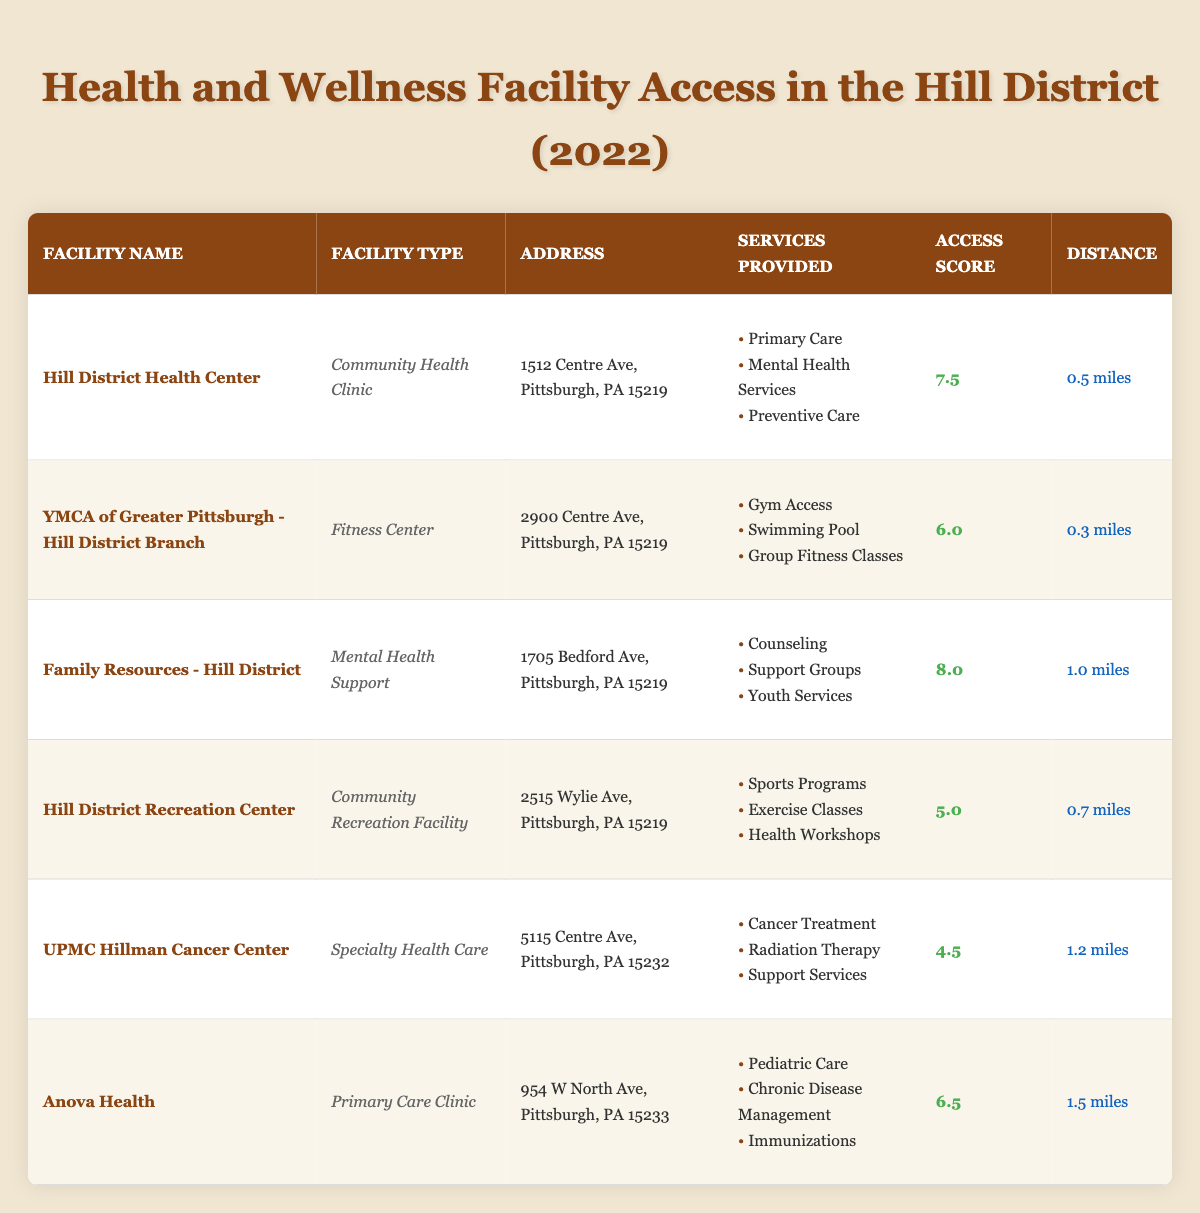What is the access score of the Hill District Health Center? The table lists the access score for the Hill District Health Center as 7.5 under the "Access Score" column.
Answer: 7.5 Which facility is closest to the center? The YMCA of Greater Pittsburgh - Hill District Branch is listed as being 0.3 miles away, which is the shortest distance among all facilities.
Answer: YMCA of Greater Pittsburgh - Hill District Branch What type of services does the Family Resources - Hill District provide? The table shows that Family Resources - Hill District provides counseling, support groups, and youth services, listed under the "Services Provided" column.
Answer: Counseling, Support Groups, Youth Services What is the average access score of the listed facilities? The access scores are 7.5, 6.0, 8.0, 5.0, 4.5, and 6.5. Their sum is 37.5 and there are 6 facilities, so the average is 37.5 / 6 = 6.25.
Answer: 6.25 Is the UPMC Hillman Cancer Center further than 1 mile from the center? The distance listed for UPMC Hillman Cancer Center is 1.2 miles, which is greater than 1 mile. Therefore, the answer is yes.
Answer: Yes Which facility has the highest access score and what is it? Scanning the "Access Score" column, Family Resources - Hill District has the highest score at 8.0.
Answer: 8.0 How many facilities provide mental health services? The Hill District Health Center and Family Resources - Hill District both provide mental health services, so there are 2 facilities offering these services.
Answer: 2 Which facility offers outdoor programs such as sports? The Hill District Recreation Center provides sports programs as part of its services, making it the relevant facility.
Answer: Hill District Recreation Center If you were to rank the facilities based on their access scores, which facility would be in the 3rd position? The scores from highest to lowest are 8.0, 7.5, 6.5, 6.0, 5.0, 4.5. Anova Health has the 3rd highest score at 6.5.
Answer: Anova Health Is there a facility that provides pediatric care? Yes, Anova Health provides pediatric care, as listed in the "Services Provided" section.
Answer: Yes 